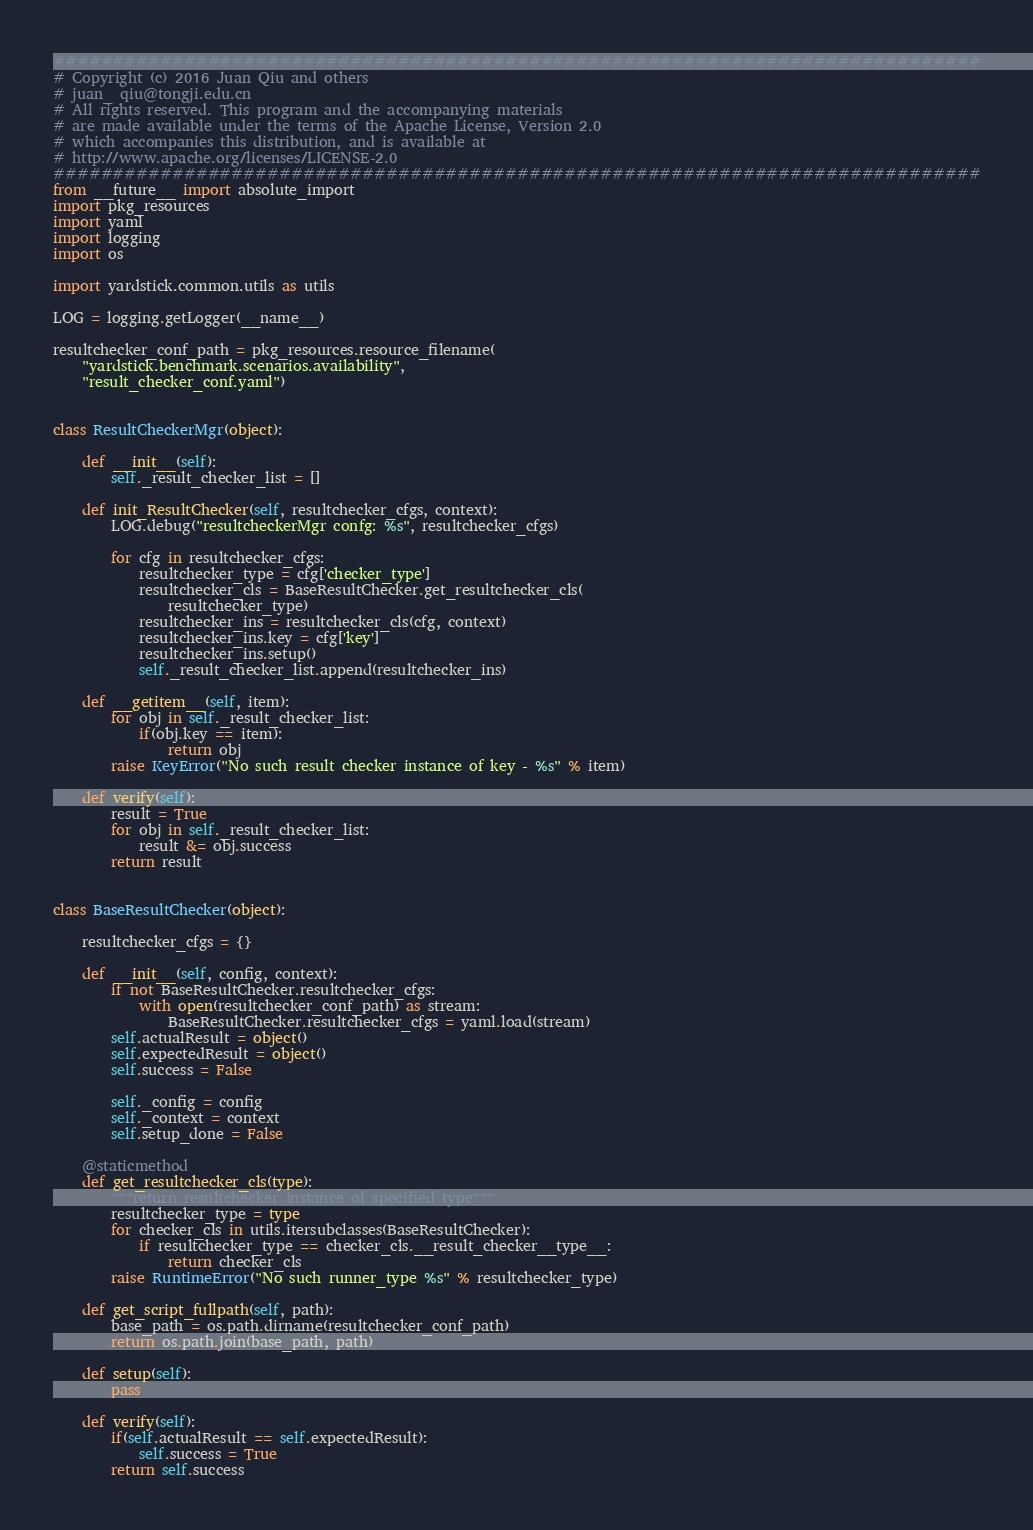Convert code to text. <code><loc_0><loc_0><loc_500><loc_500><_Python_>##############################################################################
# Copyright (c) 2016 Juan Qiu and others
# juan_ qiu@tongji.edu.cn
# All rights reserved. This program and the accompanying materials
# are made available under the terms of the Apache License, Version 2.0
# which accompanies this distribution, and is available at
# http://www.apache.org/licenses/LICENSE-2.0
##############################################################################
from __future__ import absolute_import
import pkg_resources
import yaml
import logging
import os

import yardstick.common.utils as utils

LOG = logging.getLogger(__name__)

resultchecker_conf_path = pkg_resources.resource_filename(
    "yardstick.benchmark.scenarios.availability",
    "result_checker_conf.yaml")


class ResultCheckerMgr(object):

    def __init__(self):
        self._result_checker_list = []

    def init_ResultChecker(self, resultchecker_cfgs, context):
        LOG.debug("resultcheckerMgr confg: %s", resultchecker_cfgs)

        for cfg in resultchecker_cfgs:
            resultchecker_type = cfg['checker_type']
            resultchecker_cls = BaseResultChecker.get_resultchecker_cls(
                resultchecker_type)
            resultchecker_ins = resultchecker_cls(cfg, context)
            resultchecker_ins.key = cfg['key']
            resultchecker_ins.setup()
            self._result_checker_list.append(resultchecker_ins)

    def __getitem__(self, item):
        for obj in self._result_checker_list:
            if(obj.key == item):
                return obj
        raise KeyError("No such result checker instance of key - %s" % item)

    def verify(self):
        result = True
        for obj in self._result_checker_list:
            result &= obj.success
        return result


class BaseResultChecker(object):

    resultchecker_cfgs = {}

    def __init__(self, config, context):
        if not BaseResultChecker.resultchecker_cfgs:
            with open(resultchecker_conf_path) as stream:
                BaseResultChecker.resultchecker_cfgs = yaml.load(stream)
        self.actualResult = object()
        self.expectedResult = object()
        self.success = False

        self._config = config
        self._context = context
        self.setup_done = False

    @staticmethod
    def get_resultchecker_cls(type):
        """return resultchecker instance of specified type"""
        resultchecker_type = type
        for checker_cls in utils.itersubclasses(BaseResultChecker):
            if resultchecker_type == checker_cls.__result_checker__type__:
                return checker_cls
        raise RuntimeError("No such runner_type %s" % resultchecker_type)

    def get_script_fullpath(self, path):
        base_path = os.path.dirname(resultchecker_conf_path)
        return os.path.join(base_path, path)

    def setup(self):
        pass

    def verify(self):
        if(self.actualResult == self.expectedResult):
            self.success = True
        return self.success
</code> 